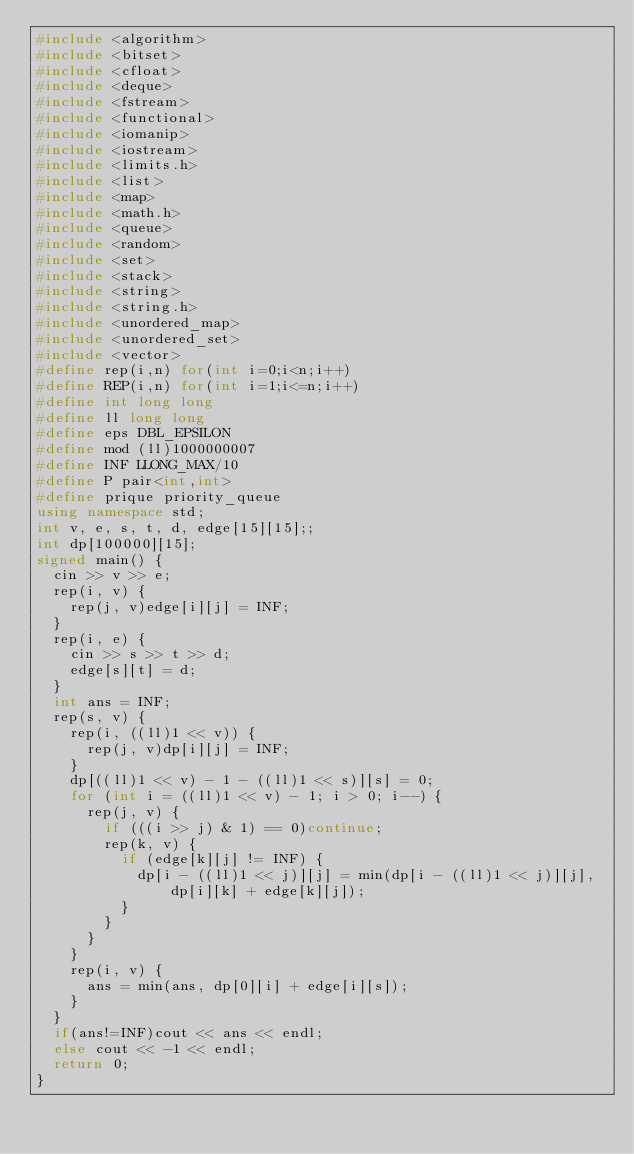<code> <loc_0><loc_0><loc_500><loc_500><_C++_>#include <algorithm>
#include <bitset>
#include <cfloat>
#include <deque>
#include <fstream>
#include <functional>
#include <iomanip>
#include <iostream>
#include <limits.h>
#include <list>
#include <map>
#include <math.h>
#include <queue>
#include <random>
#include <set>
#include <stack>
#include <string>
#include <string.h>
#include <unordered_map>
#include <unordered_set>
#include <vector>
#define rep(i,n) for(int i=0;i<n;i++)
#define REP(i,n) for(int i=1;i<=n;i++)
#define int long long
#define ll long long
#define eps DBL_EPSILON
#define mod (ll)1000000007
#define INF LLONG_MAX/10
#define P pair<int,int>
#define prique priority_queue
using namespace std;
int v, e, s, t, d, edge[15][15];;
int dp[100000][15];
signed main() {
	cin >> v >> e;
	rep(i, v) {
		rep(j, v)edge[i][j] = INF;
	}
	rep(i, e) {
		cin >> s >> t >> d;
		edge[s][t] = d;
	}
	int ans = INF;
	rep(s, v) {
		rep(i, ((ll)1 << v)) {
			rep(j, v)dp[i][j] = INF;
		}
		dp[((ll)1 << v) - 1 - ((ll)1 << s)][s] = 0;
		for (int i = ((ll)1 << v) - 1; i > 0; i--) {
			rep(j, v) {
				if (((i >> j) & 1) == 0)continue;
				rep(k, v) {
					if (edge[k][j] != INF) {
						dp[i - ((ll)1 << j)][j] = min(dp[i - ((ll)1 << j)][j], dp[i][k] + edge[k][j]);
					}
				}
			}
		}
		rep(i, v) {
			ans = min(ans, dp[0][i] + edge[i][s]);
		}
	}
	if(ans!=INF)cout << ans << endl;
	else cout << -1 << endl;
	return 0;
}
</code> 